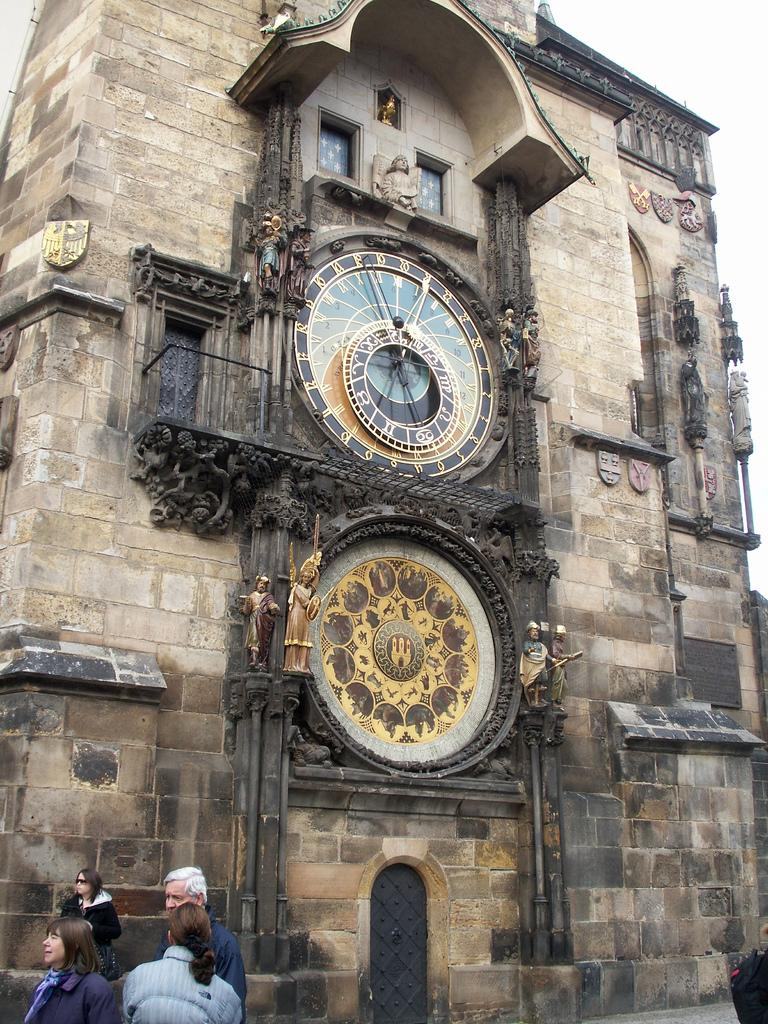What can be seen on the left side of the image? There are people standing on the left side of the image. What type of structure is present in the image? There is a building in the image. What feature does the building have? The building has a clock. Are there any decorative elements on the building? Yes, the building has sculptures. How much honey is being used to light the building in the image? There is no honey being used to light the building in the image. What type of punishment is being administered to the people on the left side of the image? There is no punishment being administered to the people on the left side of the image. 